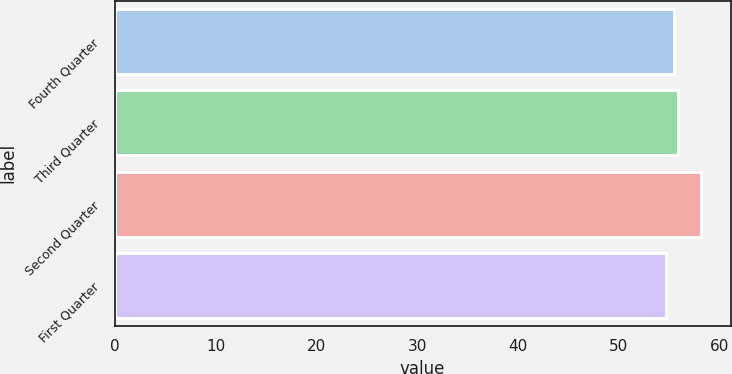<chart> <loc_0><loc_0><loc_500><loc_500><bar_chart><fcel>Fourth Quarter<fcel>Third Quarter<fcel>Second Quarter<fcel>First Quarter<nl><fcel>55.5<fcel>55.85<fcel>58.19<fcel>54.67<nl></chart> 